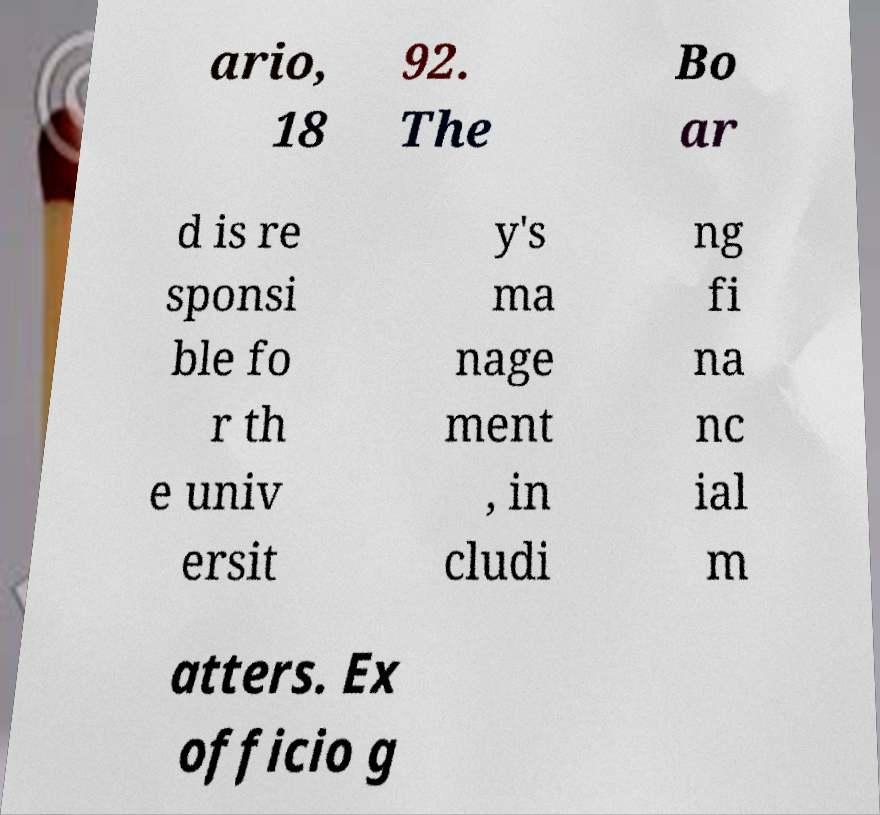There's text embedded in this image that I need extracted. Can you transcribe it verbatim? ario, 18 92. The Bo ar d is re sponsi ble fo r th e univ ersit y's ma nage ment , in cludi ng fi na nc ial m atters. Ex officio g 